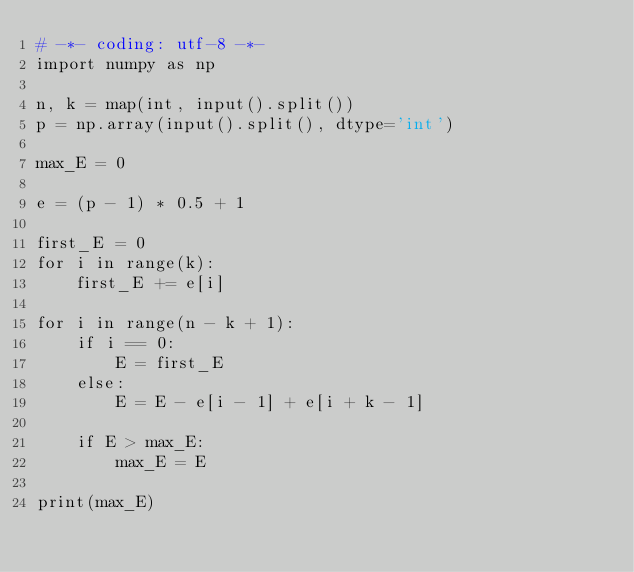Convert code to text. <code><loc_0><loc_0><loc_500><loc_500><_Python_># -*- coding: utf-8 -*-
import numpy as np

n, k = map(int, input().split())
p = np.array(input().split(), dtype='int')

max_E = 0

e = (p - 1) * 0.5 + 1

first_E = 0
for i in range(k):
    first_E += e[i]

for i in range(n - k + 1):
    if i == 0:
        E = first_E
    else:
        E = E - e[i - 1] + e[i + k - 1]
    
    if E > max_E:
        max_E = E

print(max_E)

    </code> 